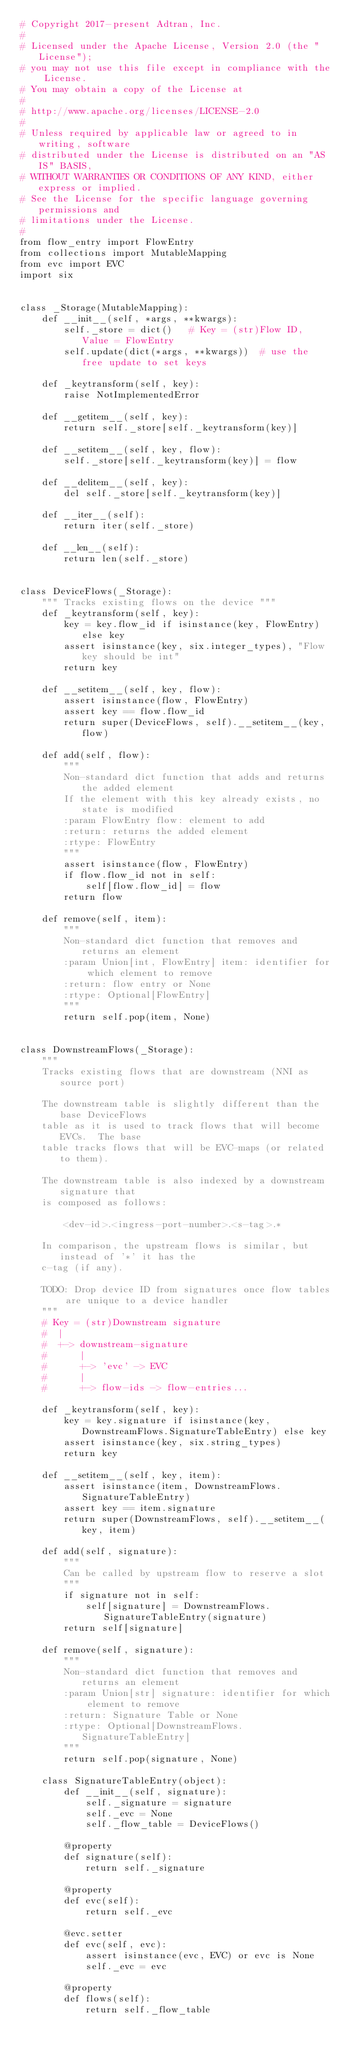Convert code to text. <code><loc_0><loc_0><loc_500><loc_500><_Python_># Copyright 2017-present Adtran, Inc.
#
# Licensed under the Apache License, Version 2.0 (the "License");
# you may not use this file except in compliance with the License.
# You may obtain a copy of the License at
#
# http://www.apache.org/licenses/LICENSE-2.0
#
# Unless required by applicable law or agreed to in writing, software
# distributed under the License is distributed on an "AS IS" BASIS,
# WITHOUT WARRANTIES OR CONDITIONS OF ANY KIND, either express or implied.
# See the License for the specific language governing permissions and
# limitations under the License.
#
from flow_entry import FlowEntry
from collections import MutableMapping
from evc import EVC
import six


class _Storage(MutableMapping):
    def __init__(self, *args, **kwargs):
        self._store = dict()   # Key = (str)Flow ID, Value = FlowEntry
        self.update(dict(*args, **kwargs))  # use the free update to set keys

    def _keytransform(self, key):
        raise NotImplementedError

    def __getitem__(self, key):
        return self._store[self._keytransform(key)]

    def __setitem__(self, key, flow):
        self._store[self._keytransform(key)] = flow

    def __delitem__(self, key):
        del self._store[self._keytransform(key)]

    def __iter__(self):
        return iter(self._store)

    def __len__(self):
        return len(self._store)


class DeviceFlows(_Storage):
    """ Tracks existing flows on the device """
    def _keytransform(self, key):
        key = key.flow_id if isinstance(key, FlowEntry) else key
        assert isinstance(key, six.integer_types), "Flow key should be int"
        return key

    def __setitem__(self, key, flow):
        assert isinstance(flow, FlowEntry)
        assert key == flow.flow_id
        return super(DeviceFlows, self).__setitem__(key, flow)

    def add(self, flow):
        """
        Non-standard dict function that adds and returns the added element
        If the element with this key already exists, no state is modified
        :param FlowEntry flow: element to add
        :return: returns the added element
        :rtype: FlowEntry
        """
        assert isinstance(flow, FlowEntry)
        if flow.flow_id not in self:
            self[flow.flow_id] = flow
        return flow

    def remove(self, item):
        """
        Non-standard dict function that removes and returns an element
        :param Union[int, FlowEntry] item: identifier for which element to remove
        :return: flow entry or None
        :rtype: Optional[FlowEntry]
        """
        return self.pop(item, None)


class DownstreamFlows(_Storage):
    """
    Tracks existing flows that are downstream (NNI as source port)

    The downstream table is slightly different than the base DeviceFlows
    table as it is used to track flows that will become EVCs.  The base
    table tracks flows that will be EVC-maps (or related to them).

    The downstream table is also indexed by a downstream signature that
    is composed as follows:

        <dev-id>.<ingress-port-number>.<s-tag>.*

    In comparison, the upstream flows is similar, but instead of '*' it has the
    c-tag (if any).

    TODO: Drop device ID from signatures once flow tables are unique to a device handler
    """
    # Key = (str)Downstream signature
    #  |
    #  +-> downstream-signature
    #      |
    #      +-> 'evc' -> EVC
    #      |
    #      +-> flow-ids -> flow-entries...

    def _keytransform(self, key):
        key = key.signature if isinstance(key, DownstreamFlows.SignatureTableEntry) else key
        assert isinstance(key, six.string_types)
        return key

    def __setitem__(self, key, item):
        assert isinstance(item, DownstreamFlows.SignatureTableEntry)
        assert key == item.signature
        return super(DownstreamFlows, self).__setitem__(key, item)

    def add(self, signature):
        """
        Can be called by upstream flow to reserve a slot
        """
        if signature not in self:
            self[signature] = DownstreamFlows.SignatureTableEntry(signature)
        return self[signature]

    def remove(self, signature):
        """
        Non-standard dict function that removes and returns an element
        :param Union[str] signature: identifier for which element to remove
        :return: Signature Table or None
        :rtype: Optional[DownstreamFlows.SignatureTableEntry]
        """
        return self.pop(signature, None)

    class SignatureTableEntry(object):
        def __init__(self, signature):
            self._signature = signature
            self._evc = None
            self._flow_table = DeviceFlows()

        @property
        def signature(self):
            return self._signature

        @property
        def evc(self):
            return self._evc

        @evc.setter
        def evc(self, evc):
            assert isinstance(evc, EVC) or evc is None
            self._evc = evc

        @property
        def flows(self):
            return self._flow_table
</code> 